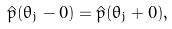Convert formula to latex. <formula><loc_0><loc_0><loc_500><loc_500>\hat { p } ( \theta _ { j } - 0 ) = \hat { p } ( \theta _ { j } + 0 ) ,</formula> 